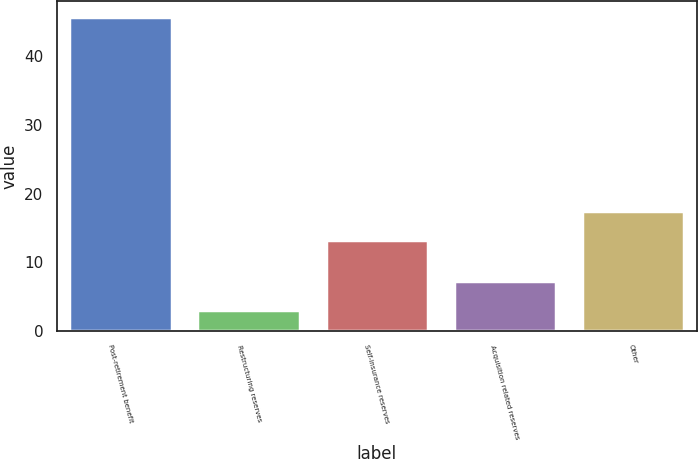Convert chart to OTSL. <chart><loc_0><loc_0><loc_500><loc_500><bar_chart><fcel>Post-retirement benefit<fcel>Restructuring reserves<fcel>Self-insurance reserves<fcel>Acquisition related reserves<fcel>Other<nl><fcel>45.8<fcel>3<fcel>13.2<fcel>7.28<fcel>17.48<nl></chart> 